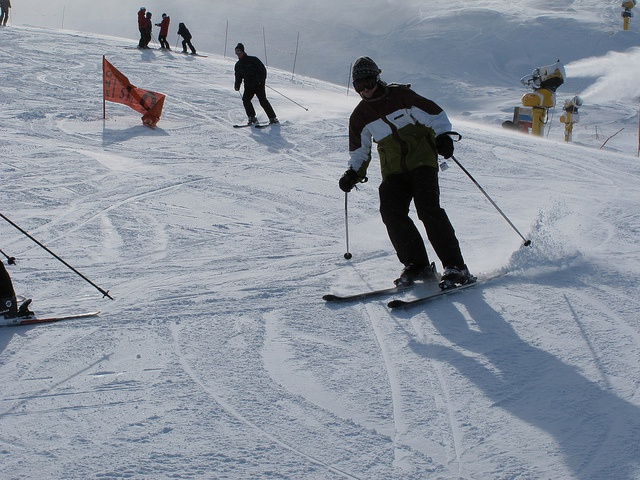Describe the objects in this image and their specific colors. I can see people in black, gray, and darkgray tones, people in black, darkgray, gray, and lightgray tones, skis in black, gray, and darkblue tones, people in black, gray, blue, and darkblue tones, and skis in black, gray, and blue tones in this image. 